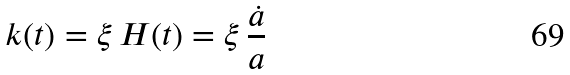<formula> <loc_0><loc_0><loc_500><loc_500>k ( t ) = \xi \, H ( t ) = \xi \, \frac { \dot { a } } { a }</formula> 